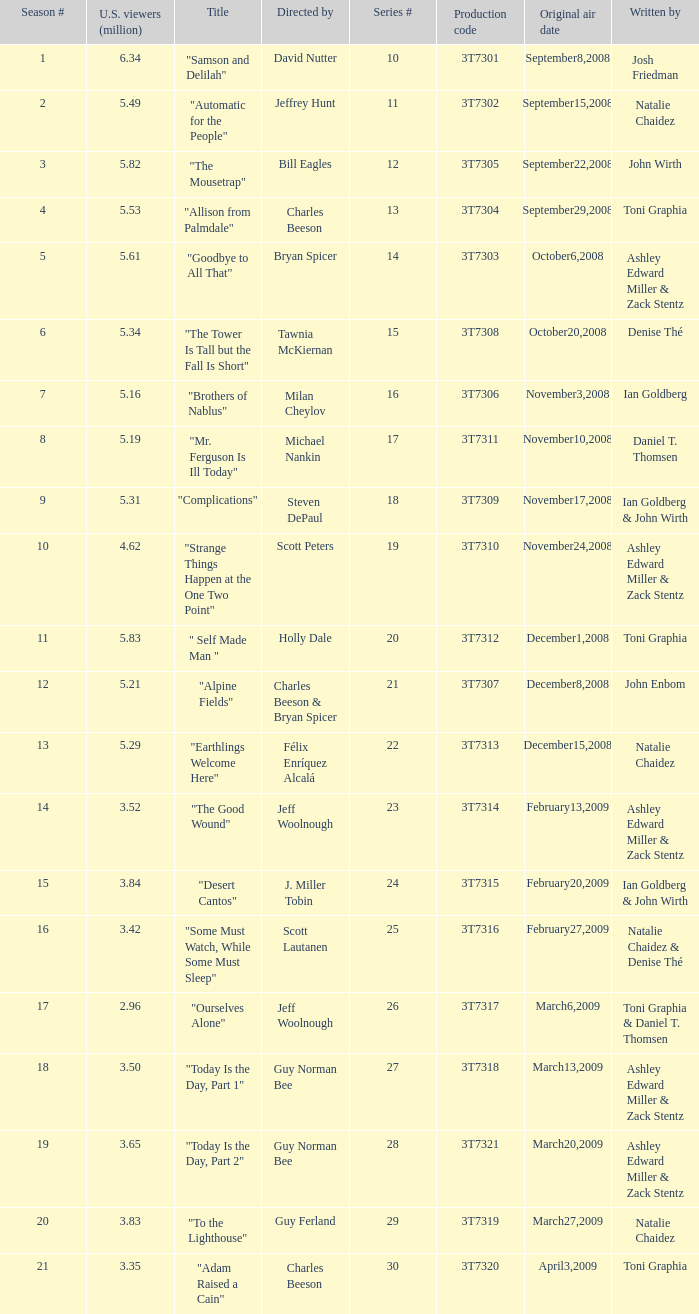Which episode number drew in 3.35 million viewers in the United States? 1.0. 